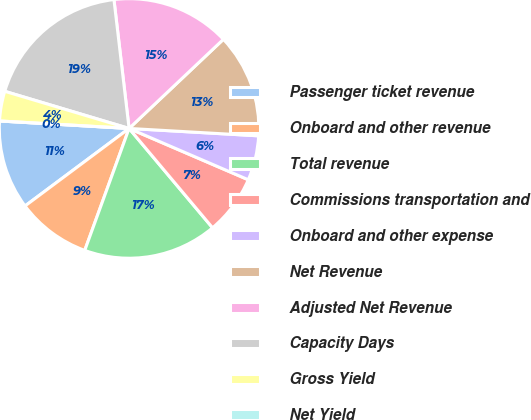Convert chart to OTSL. <chart><loc_0><loc_0><loc_500><loc_500><pie_chart><fcel>Passenger ticket revenue<fcel>Onboard and other revenue<fcel>Total revenue<fcel>Commissions transportation and<fcel>Onboard and other expense<fcel>Net Revenue<fcel>Adjusted Net Revenue<fcel>Capacity Days<fcel>Gross Yield<fcel>Net Yield<nl><fcel>11.11%<fcel>9.26%<fcel>16.67%<fcel>7.41%<fcel>5.56%<fcel>12.96%<fcel>14.81%<fcel>18.52%<fcel>3.7%<fcel>0.0%<nl></chart> 